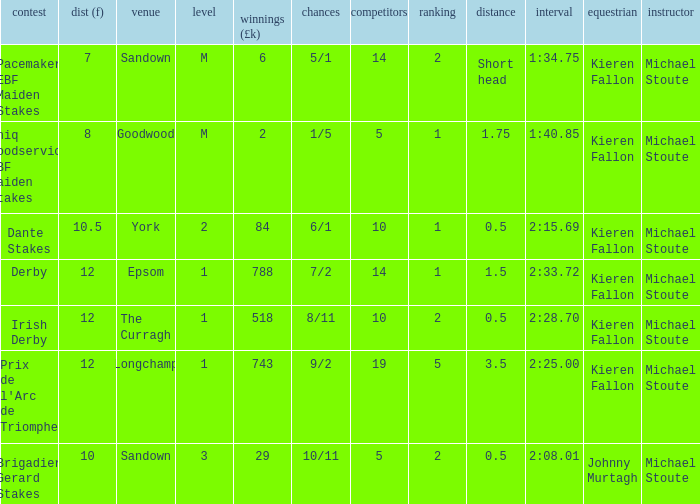Could you help me parse every detail presented in this table? {'header': ['contest', 'dist (f)', 'venue', 'level', 'winnings (£k)', 'chances', 'competitors', 'ranking', 'distance', 'interval', 'equestrian', 'instructor'], 'rows': [['Pacemaker EBF Maiden Stakes', '7', 'Sandown', 'M', '6', '5/1', '14', '2', 'Short head', '1:34.75', 'Kieren Fallon', 'Michael Stoute'], ['Uniq Foodservice EBF Maiden Stakes', '8', 'Goodwood', 'M', '2', '1/5', '5', '1', '1.75', '1:40.85', 'Kieren Fallon', 'Michael Stoute'], ['Dante Stakes', '10.5', 'York', '2', '84', '6/1', '10', '1', '0.5', '2:15.69', 'Kieren Fallon', 'Michael Stoute'], ['Derby', '12', 'Epsom', '1', '788', '7/2', '14', '1', '1.5', '2:33.72', 'Kieren Fallon', 'Michael Stoute'], ['Irish Derby', '12', 'The Curragh', '1', '518', '8/11', '10', '2', '0.5', '2:28.70', 'Kieren Fallon', 'Michael Stoute'], ["Prix de l'Arc de Triomphe", '12', 'Longchamp', '1', '743', '9/2', '19', '5', '3.5', '2:25.00', 'Kieren Fallon', 'Michael Stoute'], ['Brigadier Gerard Stakes', '10', 'Sandown', '3', '29', '10/11', '5', '2', '0.5', '2:08.01', 'Johnny Murtagh', 'Michael Stoute']]} Name the runners for longchamp 19.0. 